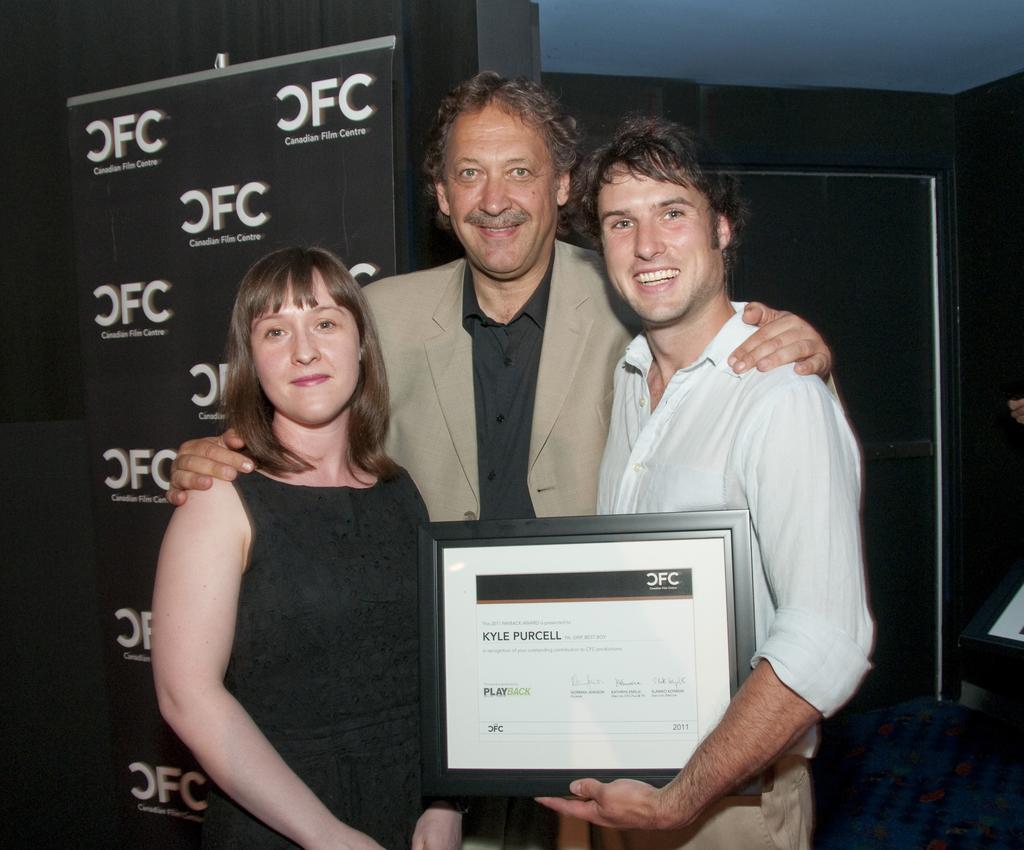How would you summarize this image in a sentence or two? In this picture we can observe three members. Two of them are men and the other is a woman. All of them are smiling. One of them is holding a frame in his hand. In the background we can observe a black color poster. 